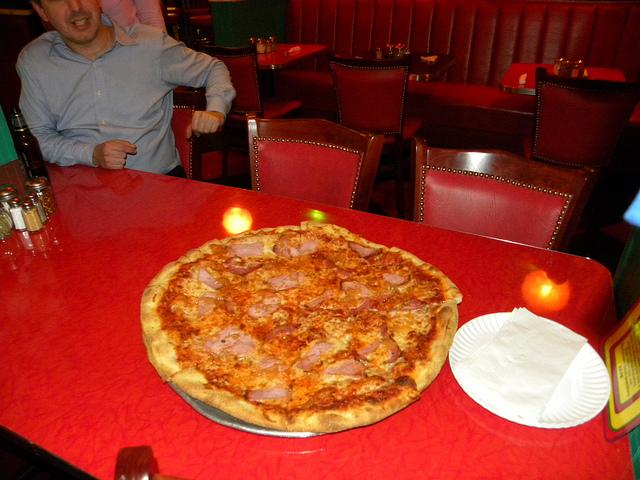What are the small candles on the table called?

Choices:
A) mini lights
B) table lights
C) tiny lights
D) tea lights table lights 